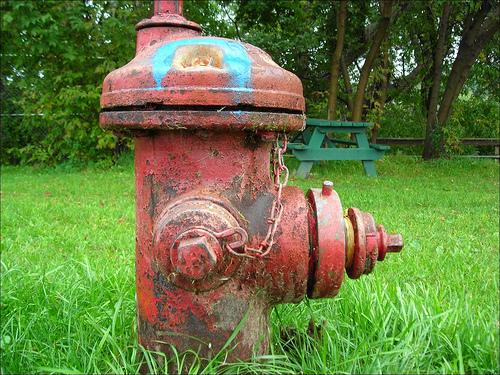Is the hydrant closed?
Quick response, please. Yes. What color is the picnic table?
Write a very short answer. Green. What is this used for?
Concise answer only. Water. 